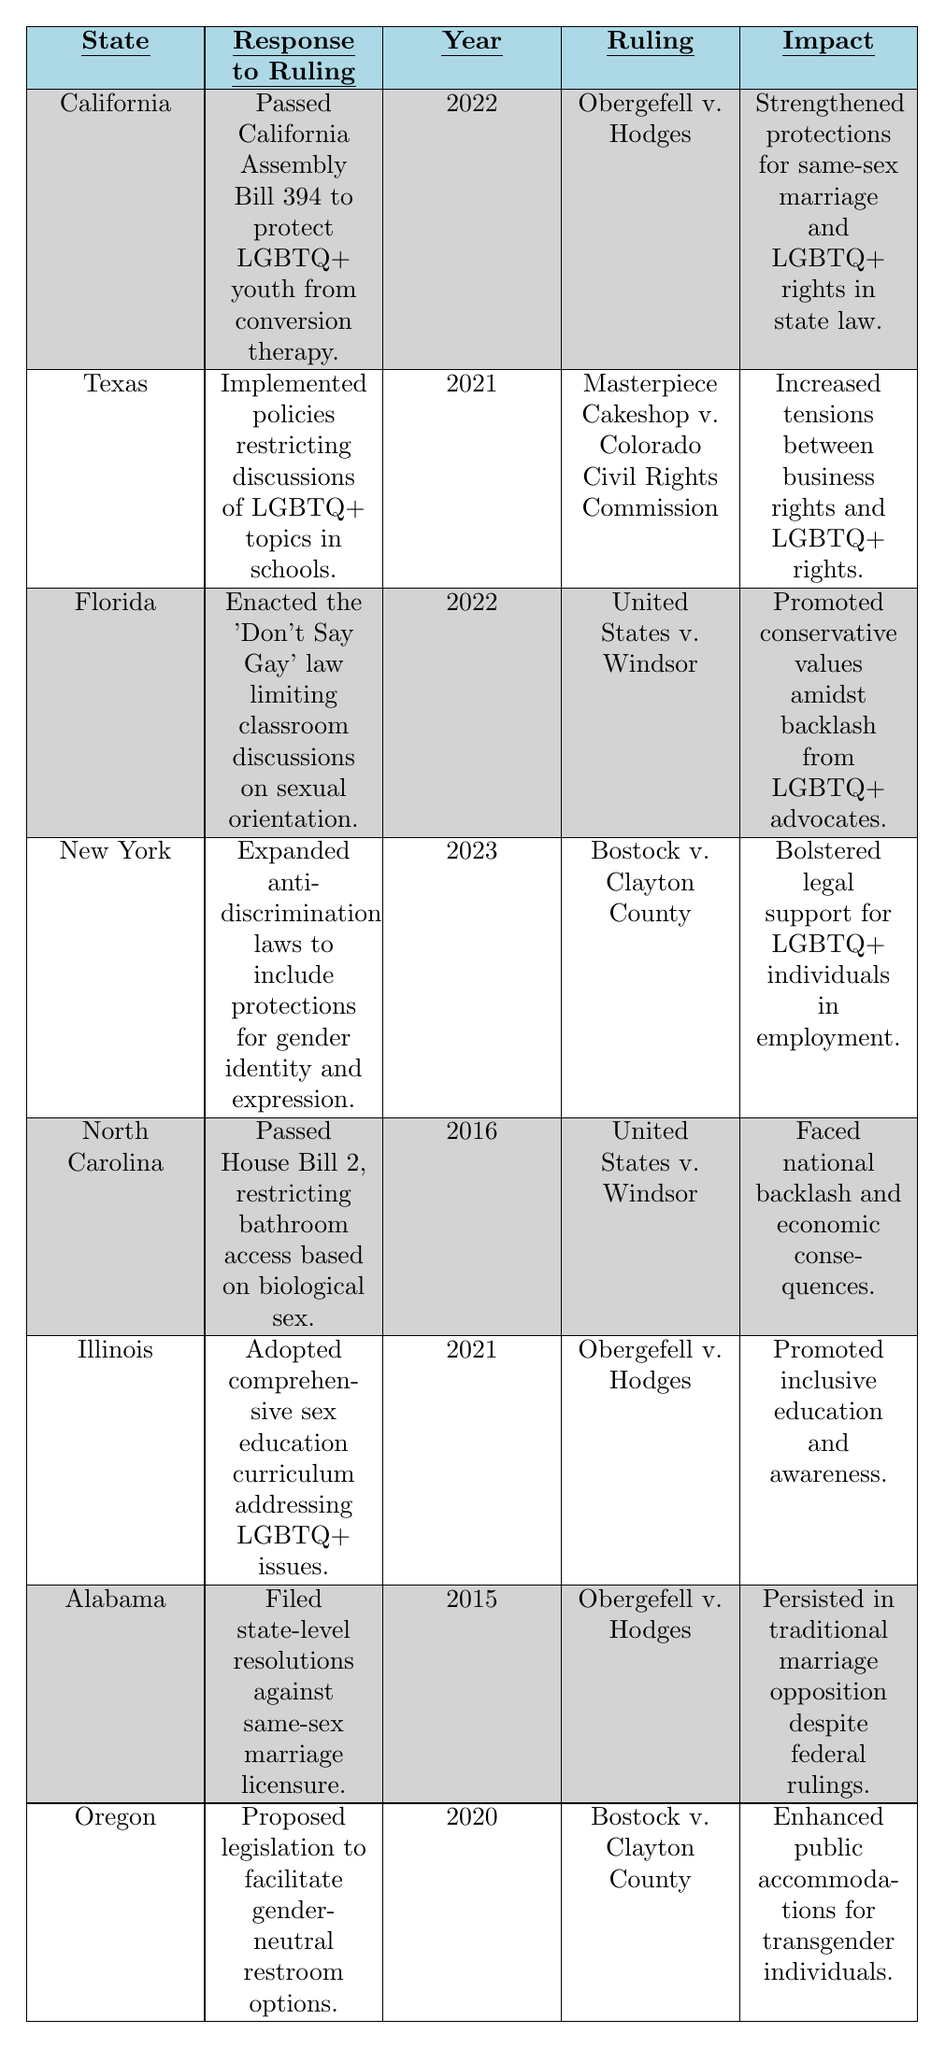What response to the Obergefell v. Hodges ruling did California enact? California passed Assembly Bill 394 to protect LGBTQ+ youth from conversion therapy in response to the Obergefell v. Hodges ruling.
Answer: Passed Assembly Bill 394 Which state responded to the Federal Ruling with policies restricting LGBTQ+ discussions in schools? Texas implemented policies that restricted discussions of LGBTQ+ topics in schools in response to the Masterpiece Cakeshop v. Colorado Civil Rights Commission ruling.
Answer: Texas How many states responded to the United States v. Windsor ruling? There are three states that responded to the United States v. Windsor ruling: Florida, North Carolina, and Texas.
Answer: Three states What was the impact of New York's response to Bostock v. Clayton County? New York expanded anti-discrimination laws to include protections for gender identity and expression, which bolstered legal support for LGBTQ+ individuals in employment.
Answer: Bolstered legal support Which state enacted legislation for gender-neutral restroom options, and in what year? Oregon proposed legislation for gender-neutral restroom options in 2020 as a response to the Bostock v. Clayton County ruling.
Answer: Oregon, 2020 What major law did Florida enact and what was its intent? Florida enacted the 'Don't Say Gay' law, which aimed to limit classroom discussions on sexual orientation, promoting conservative values.
Answer: 'Don't Say Gay' law Which state had the earliest response to Obergefell v. Hodges and what was it? Alabama filed state-level resolutions against same-sex marriage licensure as the earliest response to Obergefell v. Hodges in 2015.
Answer: Alabama, filed resolutions Which state's action faced national backlash and what triggered that? North Carolina faced national backlash after passing House Bill 2, which restricted bathroom access based on biological sex in response to the United States v. Windsor ruling.
Answer: North Carolina Identify the year when Illinois adopted a comprehensive sex education curriculum. Illinois adopted a comprehensive sex education curriculum addressing LGBTQ+ issues in 2021 in response to the Obergefell v. Hodges ruling.
Answer: 2021 